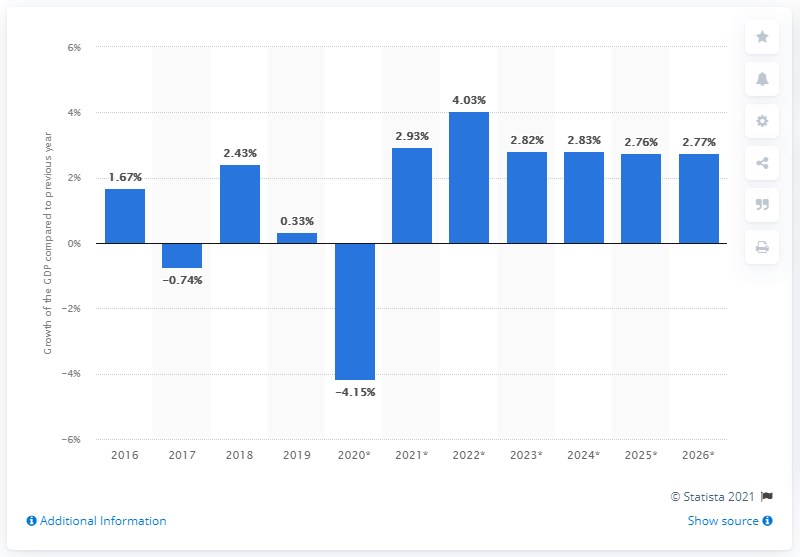Give some essential details in this illustration. In 2016, Saudi Arabia's Gross Domestic Product (GDP) grew by 0.33 percent. Saudi Arabia's Gross Domestic Product (GDP) grew by 0.33% in 2019. 